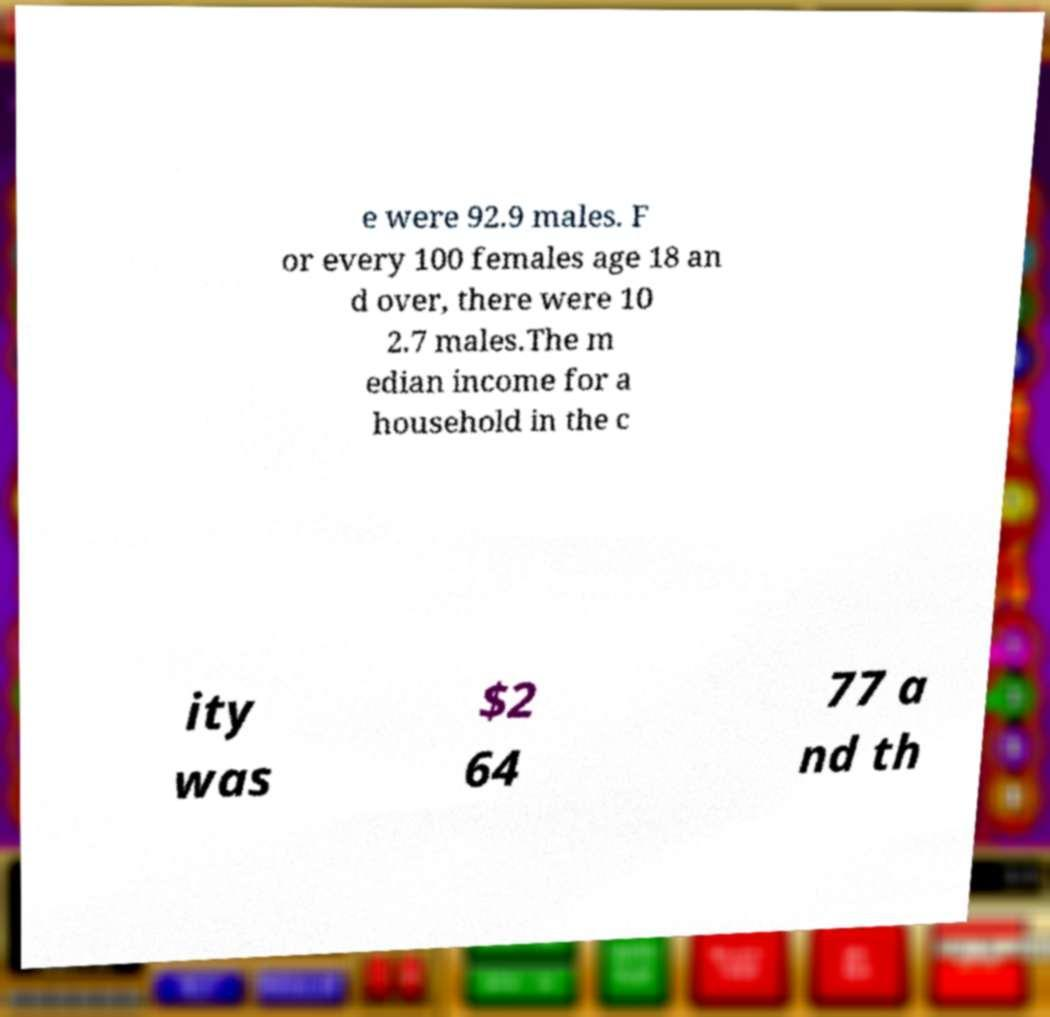Could you assist in decoding the text presented in this image and type it out clearly? e were 92.9 males. F or every 100 females age 18 an d over, there were 10 2.7 males.The m edian income for a household in the c ity was $2 64 77 a nd th 